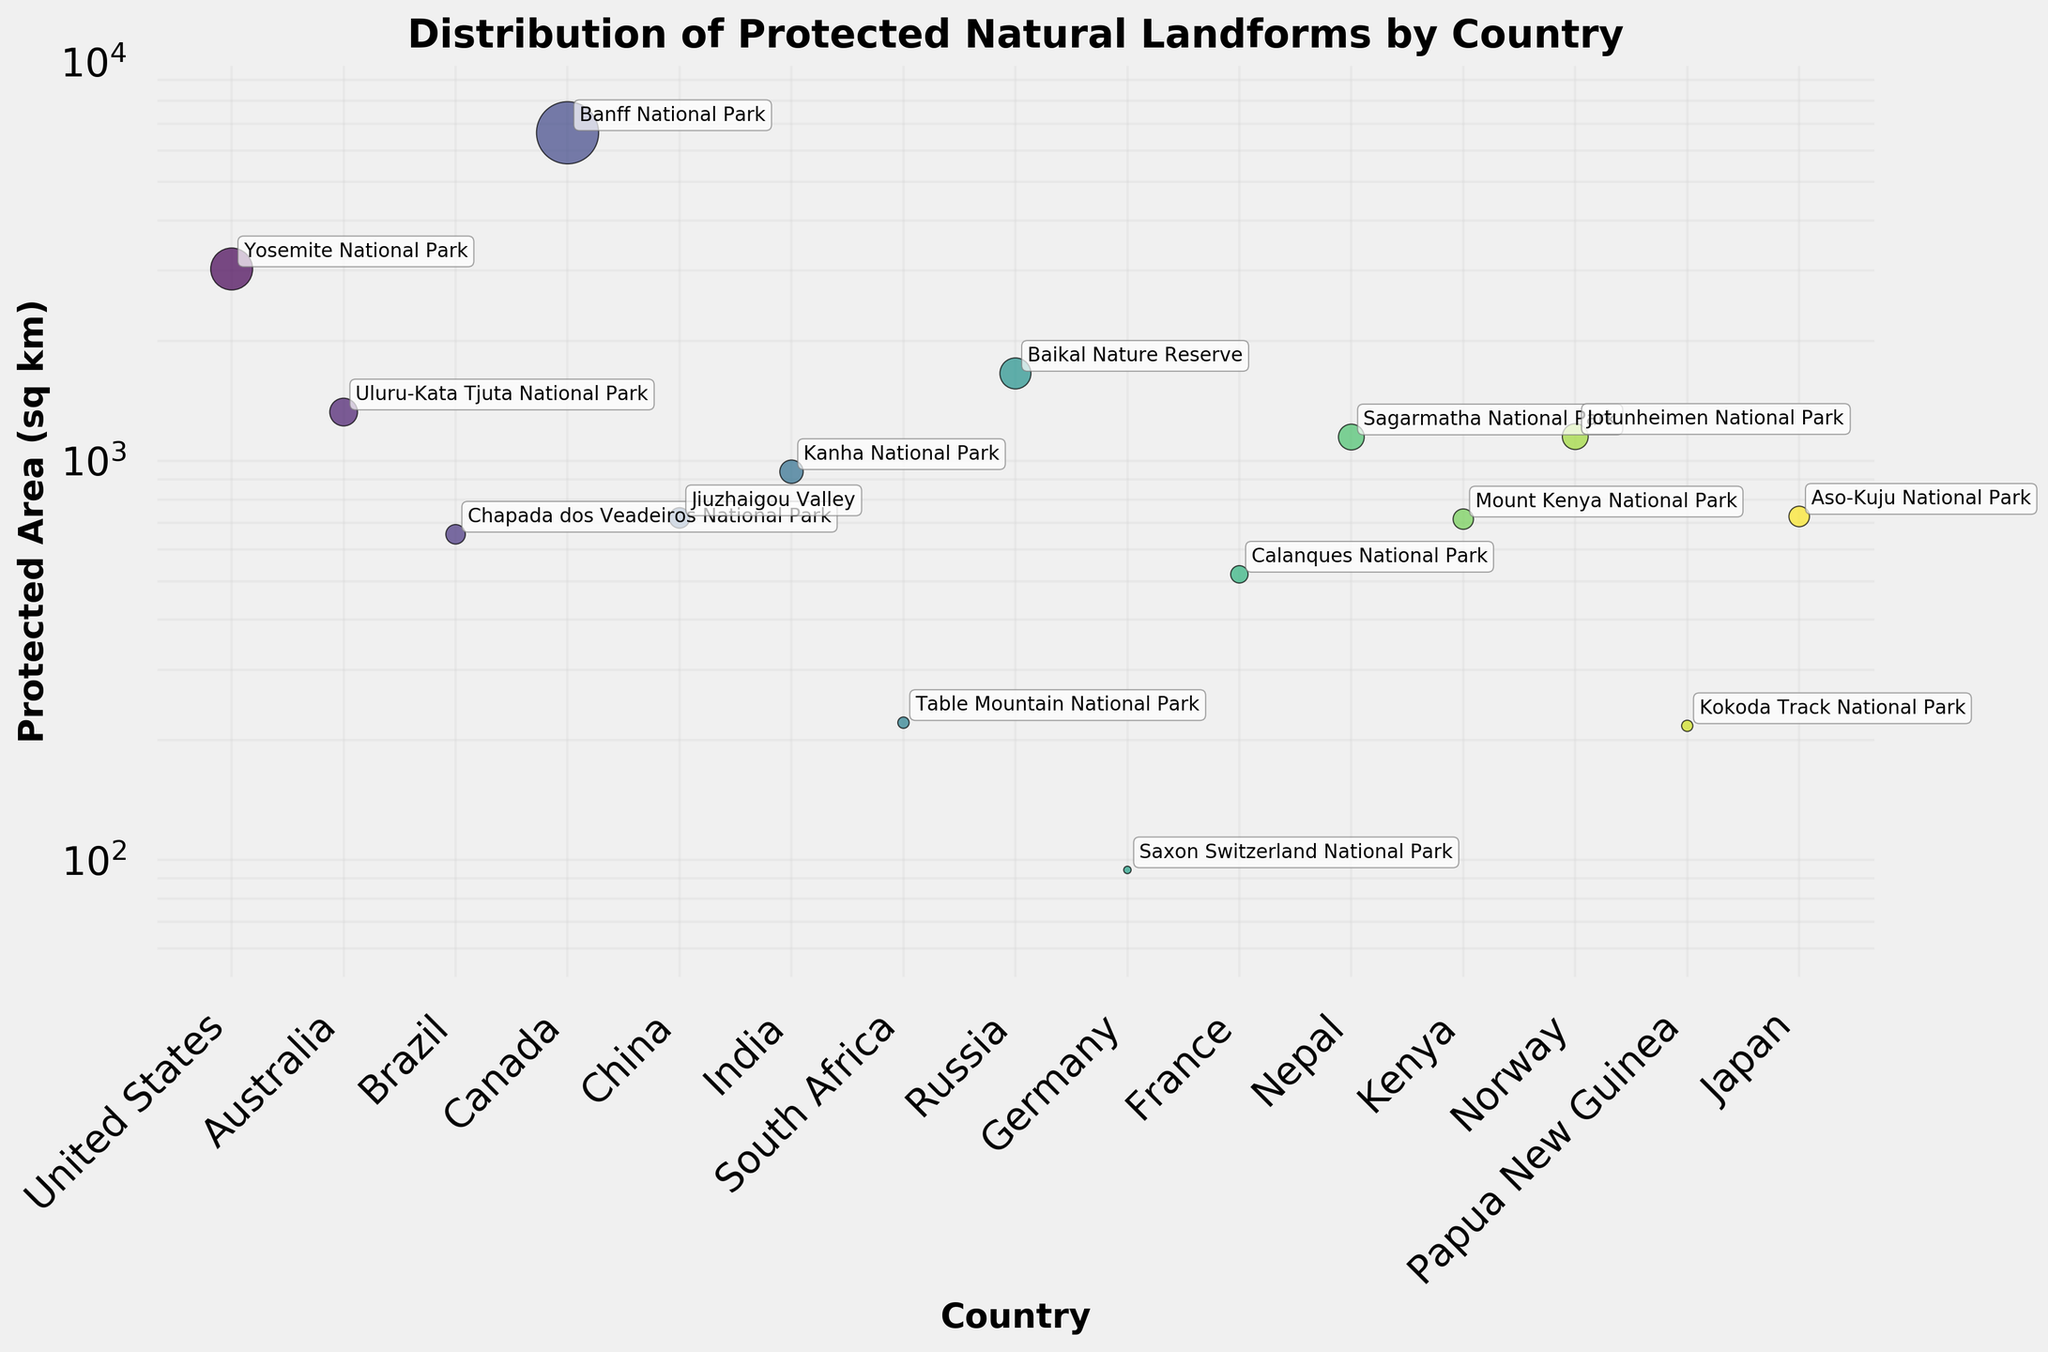what is the title of the figure? The title is usually located at the top of the figure. In this case, it reads "Distribution of Protected Natural Landforms by Country".
Answer: Distribution of Protected Natural Landforms by Country which country has the smallest protected area in the figure? You can determine this by looking at the smallest point on the y-axis of the plot. The smallest area is for "Saxon Switzerland National Park" in Germany.
Answer: Germany how many total countries are displayed in the figure? To find the total number of countries, you count the number of unique points on the x-axis. There are 15 unique countries shown.
Answer: 15 which protected area is marked in the United States? By referring to the annotated labels beside the points, the protected area marked for the United States is "Yosemite National Park".
Answer: Yosemite National Park which country has the largest protected area? To find the largest protected area, you look for the highest point on the y-axis. The country with the largest area in the figure is Canada with Banff National Park.
Answer: Canada what is the range of protected area sizes displayed in the figure? To determine the range, you identify the smallest and largest values on the y-axis. The smallest value is 94.5 sq km (Germany) and the largest is 6641 sq km (Canada). So, the range is 94.5 to 6641 sq km.
Answer: 94.5 to 6641 sq km what is the average size of the protected areas in the figure? To find the average size, sum all the area sizes and then divide by the number of data points. The sum of areas is 26,361.5 sq km and there are 15 data points. Therefore, the average size is 26,361.5 / 15 = 1757.43 sq km.
Answer: 1757.43 sq km which countries have protected areas larger than 1000 sq km? To find countries with protected areas larger than 1000 sq km, locate points above the 1000 mark on the y-axis. These countries are the United States, Australia, Canada, Russia, Nepal, and Norway.
Answer: United States, Australia, Canada, Russia, Nepal, Norway what is the combined area of the protected areas in South Africa, France, and Japan? To find the combined area, sum the areas for these three countries. South Africa has 221 sq km, France has 520 sq km, and Japan has 726 sq km. The total is 221 + 520 + 726 = 1467 sq km.
Answer: 1467 sq km is the protected area in India larger or smaller than in Brazil? Compare the points for India and Brazil. India’s Kanha National Park has 940 sq km, while Brazil’s Chapada dos Veadeiros National Park has 655 sq km. Therefore, India's protected area is larger.
Answer: larger 